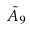<formula> <loc_0><loc_0><loc_500><loc_500>\tilde { A } _ { 9 }</formula> 